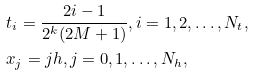Convert formula to latex. <formula><loc_0><loc_0><loc_500><loc_500>& t _ { i } = \frac { 2 i - 1 } { 2 ^ { k } ( 2 M + 1 ) } , i = 1 , 2 , \dots , N _ { t } , \\ & x _ { j } = j h , j = 0 , 1 , \dots , N _ { h } ,</formula> 